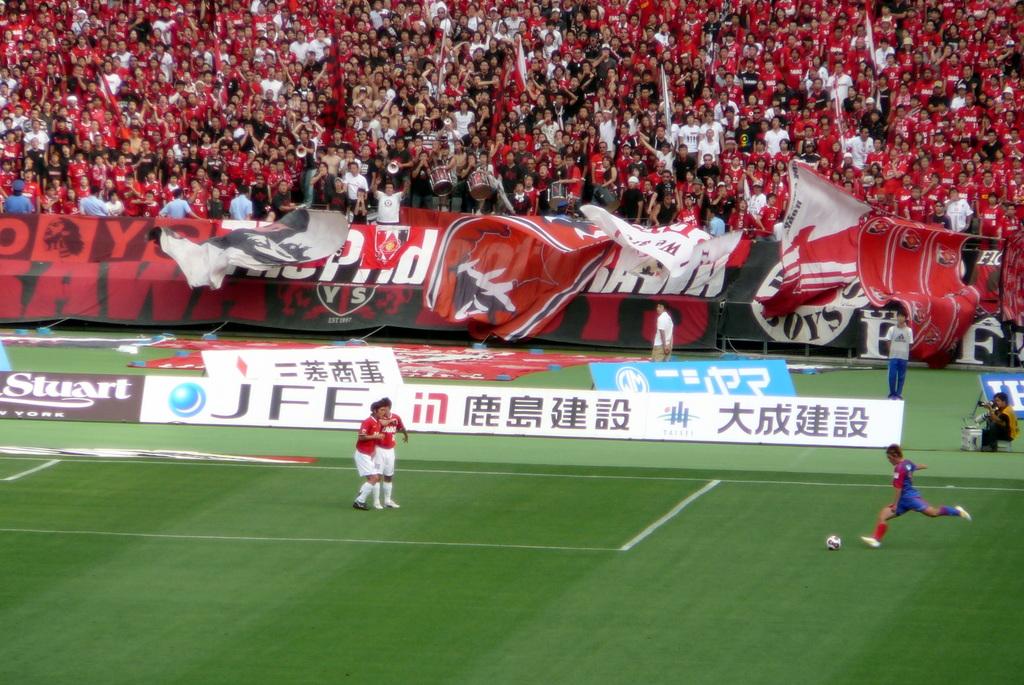What word is in white on the black sign?
Your response must be concise. Stuart. What are the three clear letters to the right of the blue ball symbol?
Offer a very short reply. Jfe. 